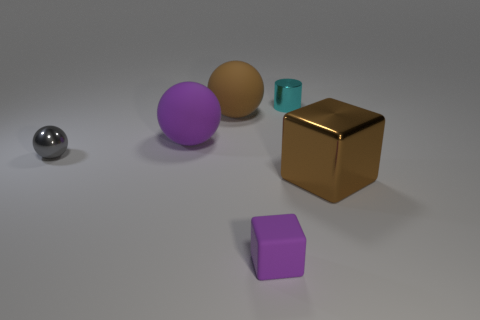Are there any big objects that have the same color as the tiny rubber cube?
Provide a succinct answer. Yes. There is a large matte thing that is the same color as the rubber block; what shape is it?
Your response must be concise. Sphere. There is a big cube; what number of gray spheres are on the left side of it?
Make the answer very short. 1. There is a object that is in front of the tiny metal sphere and left of the small cyan object; what material is it?
Ensure brevity in your answer.  Rubber. How many blocks are small objects or large things?
Provide a short and direct response. 2. What is the material of the tiny gray object that is the same shape as the brown rubber object?
Provide a short and direct response. Metal. What is the size of the cylinder that is the same material as the gray ball?
Make the answer very short. Small. There is a brown object that is to the right of the big brown matte object; does it have the same shape as the purple object behind the tiny purple matte thing?
Offer a terse response. No. What is the color of the small sphere that is the same material as the large brown block?
Make the answer very short. Gray. There is a brown thing to the right of the brown matte object; is its size the same as the gray thing that is left of the tiny metal cylinder?
Your answer should be very brief. No. 